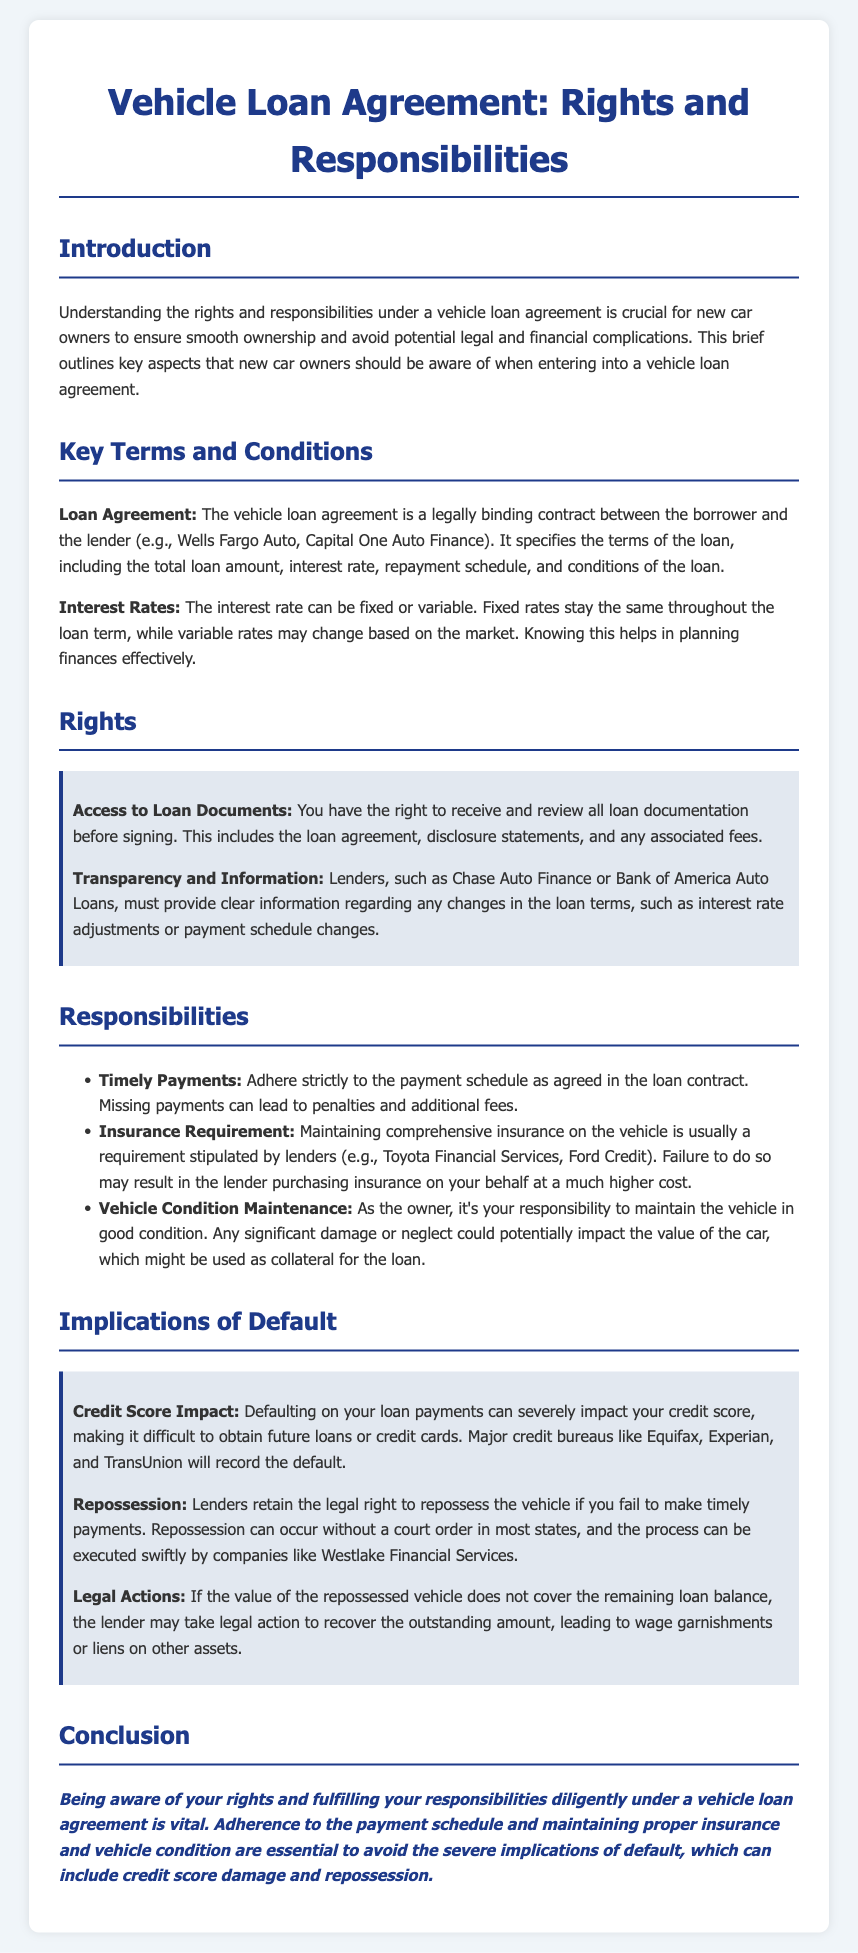What is the title of the document? The title of the document is the main heading that identifies the content, which in this case is "Vehicle Loan Agreement: Rights and Responsibilities."
Answer: Vehicle Loan Agreement: Rights and Responsibilities Who are common lenders mentioned in the document? The document mentions specific lenders in the context of vehicle loans, including Wells Fargo Auto, Chase Auto Finance, and Bank of America Auto Loans.
Answer: Wells Fargo Auto, Chase Auto Finance, Bank of America Auto Loans What is a key responsibility for vehicle owners under the loan agreement? A key responsibility highlighted in the document is the necessity for timely payments according to the payment schedule outlined in the loan contract.
Answer: Timely Payments What is the consequence of defaulting on loan payments? The document outlines several implications of defaulting, one being a significant impact on the borrower’s credit score as a result of missed payments.
Answer: Credit Score Impact What is required regarding vehicle insurance? It specifies that maintaining comprehensive insurance on the vehicle is usually a requirement stipulated by lenders.
Answer: Insurance Requirement What happens if the vehicle is repossessed? The document explains that if the vehicle is repossessed, the lender has the right to recover any outstanding loan amount if the sale of the vehicle does not cover it.
Answer: Repossession How must lenders provide information about loan changes? Lenders must provide clear information regarding any changes in the loan terms, such as interest rate adjustments or payment schedule changes.
Answer: Transparency and Information What is the impact of timely payments on vehicle loans? Adherence to the payment schedule helps avoid penalties and fees that might arise from missed payments or defaulting.
Answer: Avoid Penalties and Fees What is the purpose of this document? The document aims to inform new car owners about their rights and responsibilities under a vehicle loan agreement to ensure smooth ownership.
Answer: Inform new car owners 